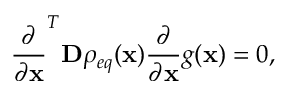<formula> <loc_0><loc_0><loc_500><loc_500>\frac { \partial } { \partial x } ^ { T } D \rho _ { e q } ( x ) \frac { \partial } { \partial x } g ( x ) = 0 ,</formula> 